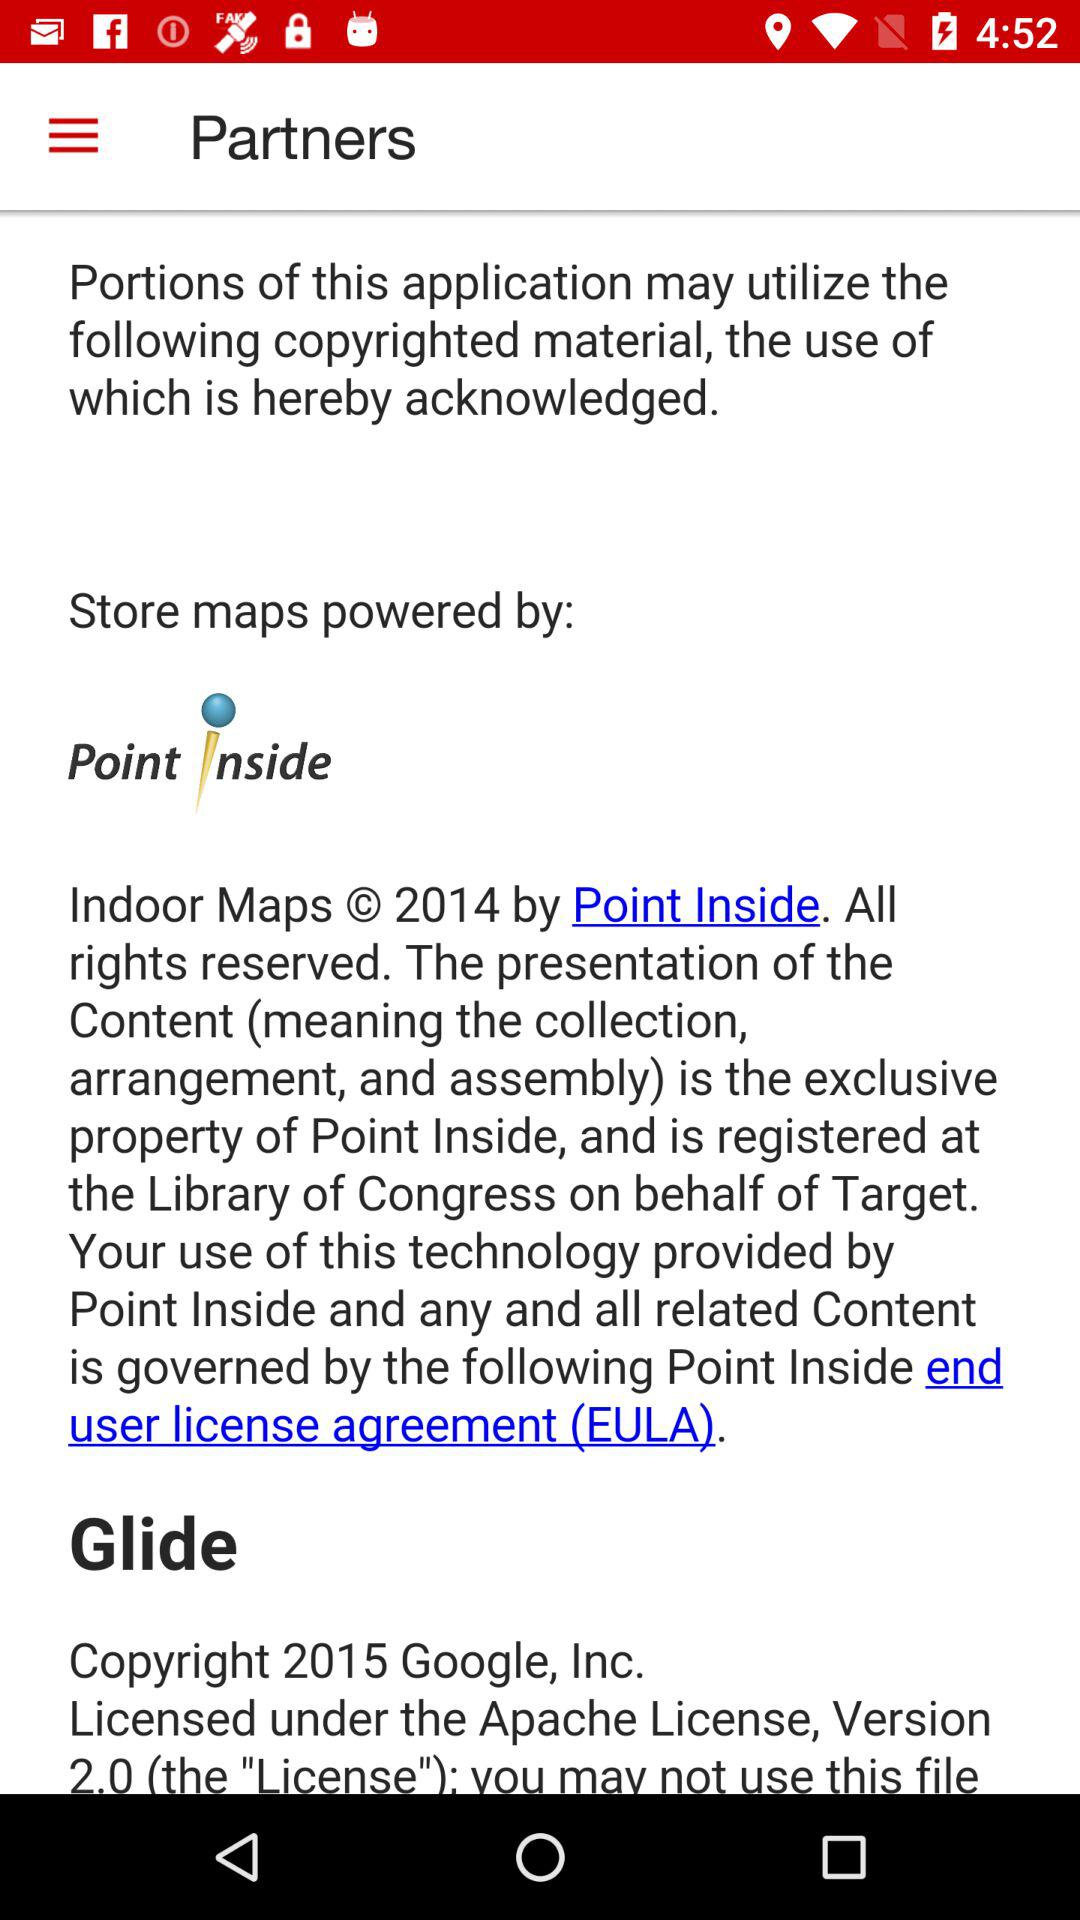How many copyrights are acknowledged in the app?
Answer the question using a single word or phrase. 2 